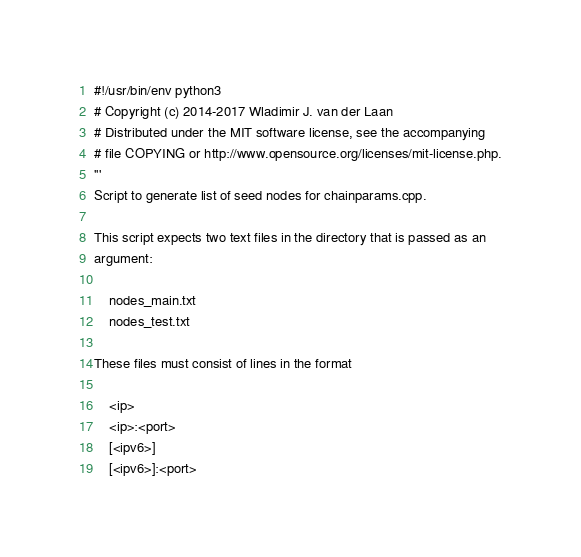Convert code to text. <code><loc_0><loc_0><loc_500><loc_500><_Python_>#!/usr/bin/env python3
# Copyright (c) 2014-2017 Wladimir J. van der Laan
# Distributed under the MIT software license, see the accompanying
# file COPYING or http://www.opensource.org/licenses/mit-license.php.
'''
Script to generate list of seed nodes for chainparams.cpp.

This script expects two text files in the directory that is passed as an
argument:

    nodes_main.txt
    nodes_test.txt

These files must consist of lines in the format

    <ip>
    <ip>:<port>
    [<ipv6>]
    [<ipv6>]:<port></code> 